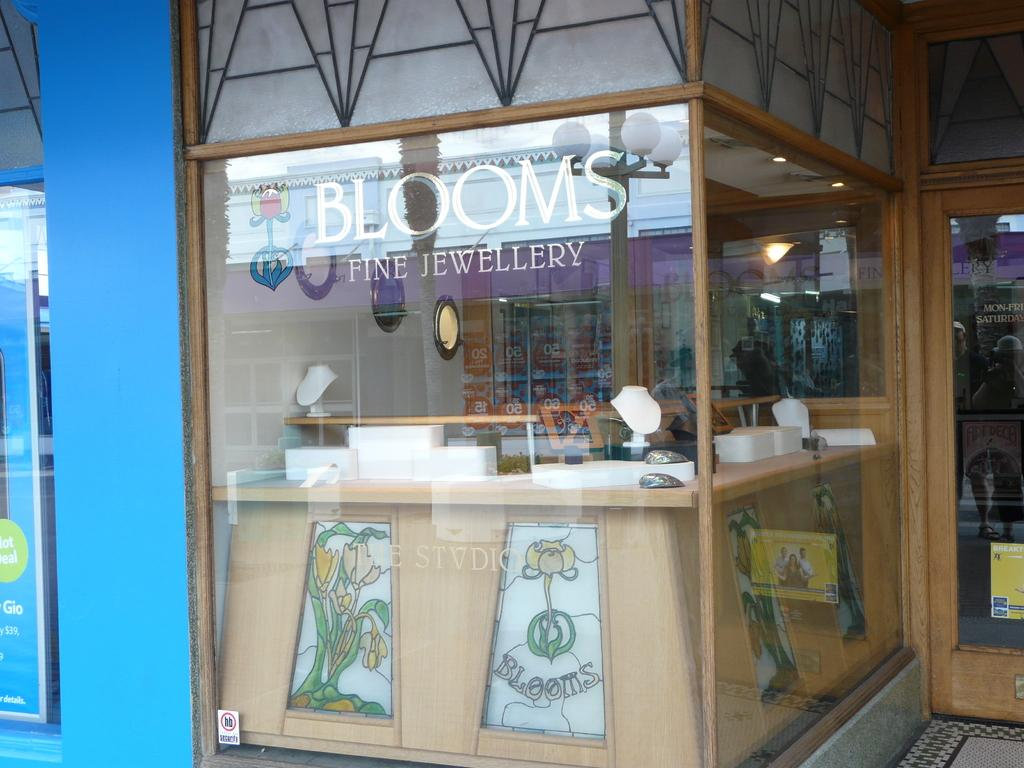<image>
Relay a brief, clear account of the picture shown. a stand that has the word Blooms on it 